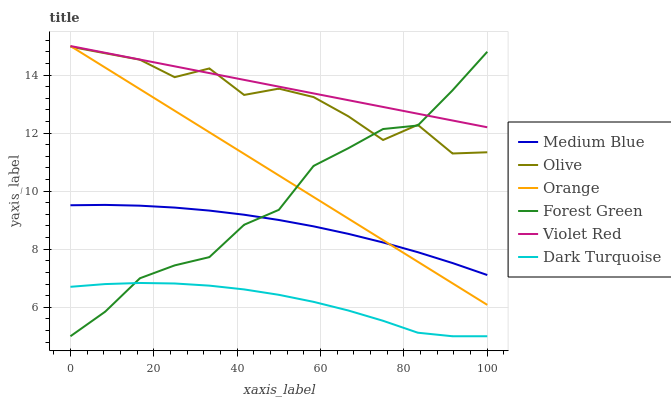Does Dark Turquoise have the minimum area under the curve?
Answer yes or no. Yes. Does Violet Red have the maximum area under the curve?
Answer yes or no. Yes. Does Medium Blue have the minimum area under the curve?
Answer yes or no. No. Does Medium Blue have the maximum area under the curve?
Answer yes or no. No. Is Orange the smoothest?
Answer yes or no. Yes. Is Olive the roughest?
Answer yes or no. Yes. Is Dark Turquoise the smoothest?
Answer yes or no. No. Is Dark Turquoise the roughest?
Answer yes or no. No. Does Dark Turquoise have the lowest value?
Answer yes or no. Yes. Does Medium Blue have the lowest value?
Answer yes or no. No. Does Orange have the highest value?
Answer yes or no. Yes. Does Medium Blue have the highest value?
Answer yes or no. No. Is Medium Blue less than Violet Red?
Answer yes or no. Yes. Is Olive greater than Medium Blue?
Answer yes or no. Yes. Does Olive intersect Violet Red?
Answer yes or no. Yes. Is Olive less than Violet Red?
Answer yes or no. No. Is Olive greater than Violet Red?
Answer yes or no. No. Does Medium Blue intersect Violet Red?
Answer yes or no. No. 